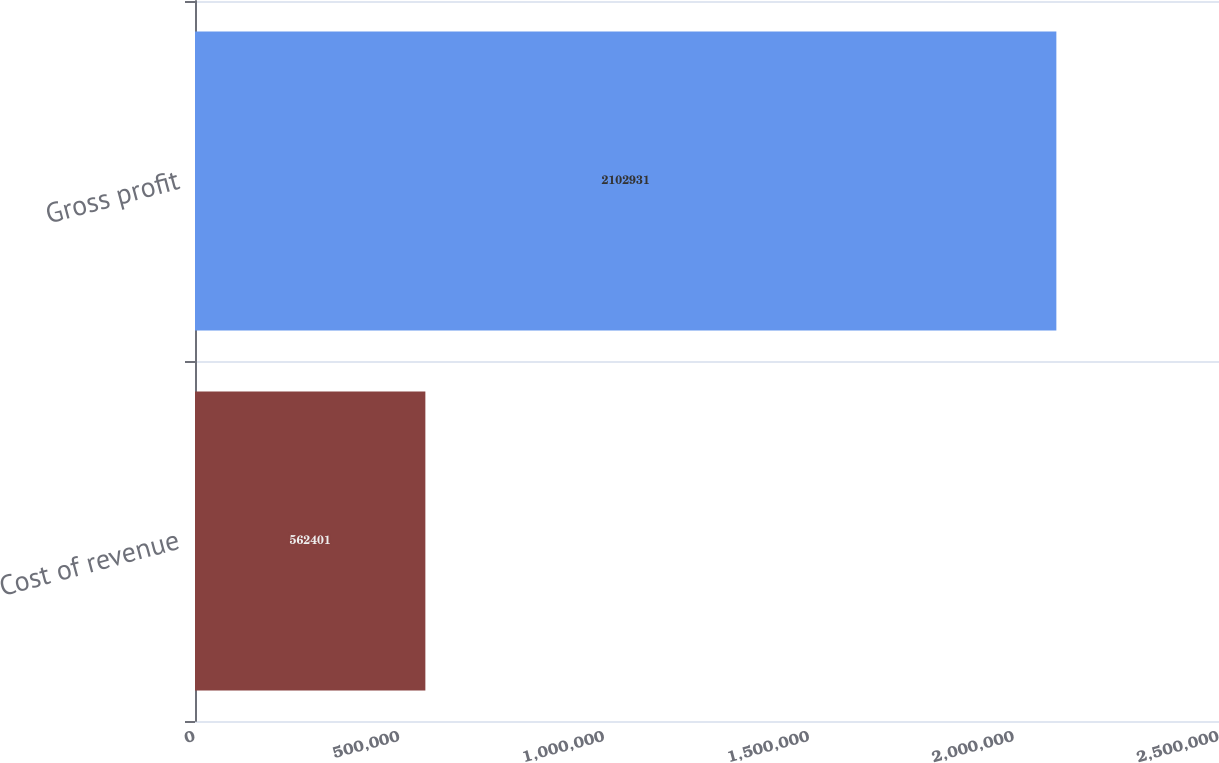Convert chart to OTSL. <chart><loc_0><loc_0><loc_500><loc_500><bar_chart><fcel>Cost of revenue<fcel>Gross profit<nl><fcel>562401<fcel>2.10293e+06<nl></chart> 